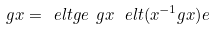Convert formula to latex. <formula><loc_0><loc_0><loc_500><loc_500>\ g x = \ e l t { g } { e } \ g x \, \ e l t { ( x ^ { - 1 } g x ) } { e }</formula> 